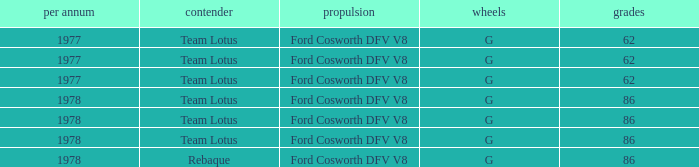What is the Focus that has a Year bigger than 1977? 86, 86, 86, 86. 